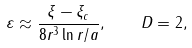Convert formula to latex. <formula><loc_0><loc_0><loc_500><loc_500>\varepsilon \approx \frac { \xi - \xi _ { c } } { 8 r ^ { 3 } \ln r / a } , \quad D = 2 ,</formula> 